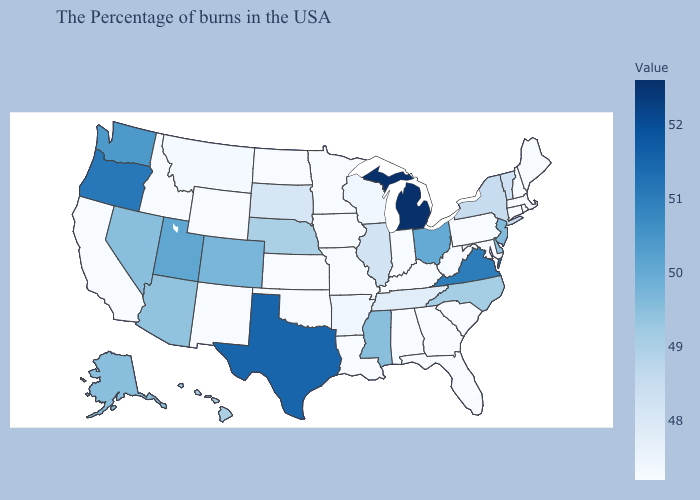Does Alaska have a lower value than Oregon?
Quick response, please. Yes. Is the legend a continuous bar?
Keep it brief. Yes. Among the states that border Delaware , which have the lowest value?
Quick response, please. Maryland, Pennsylvania. Does Kentucky have the lowest value in the South?
Concise answer only. Yes. Which states have the highest value in the USA?
Concise answer only. Michigan. 